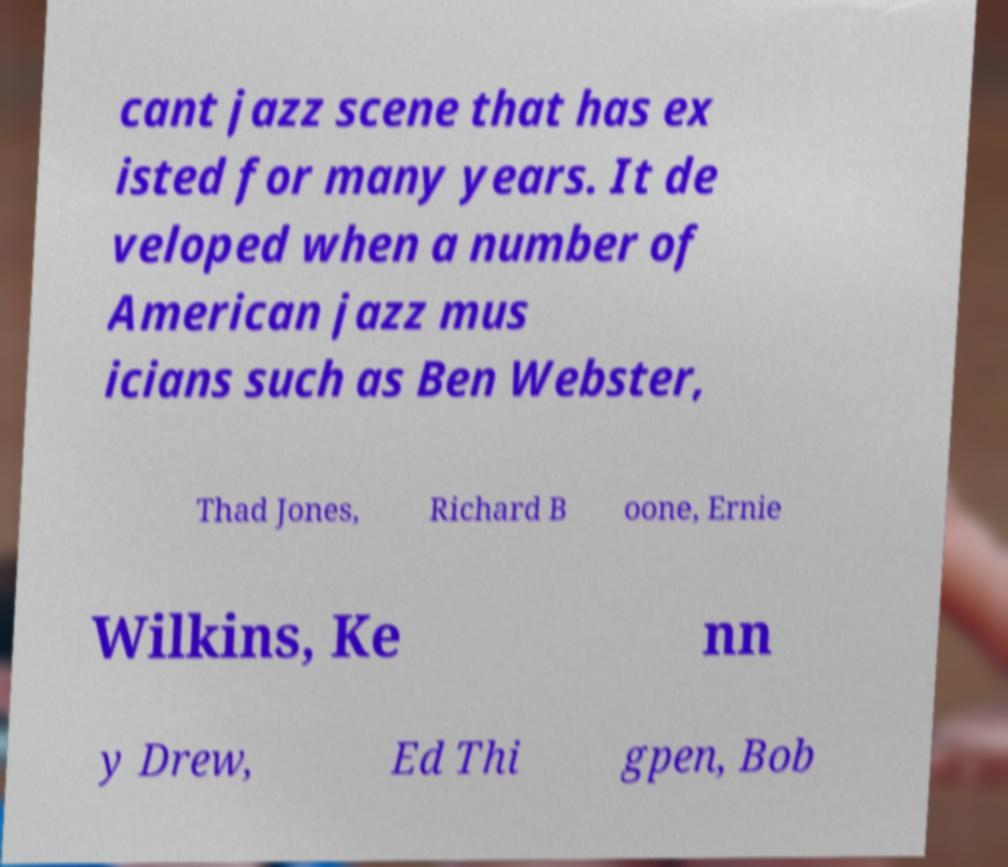Can you accurately transcribe the text from the provided image for me? cant jazz scene that has ex isted for many years. It de veloped when a number of American jazz mus icians such as Ben Webster, Thad Jones, Richard B oone, Ernie Wilkins, Ke nn y Drew, Ed Thi gpen, Bob 